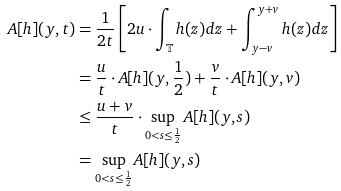<formula> <loc_0><loc_0><loc_500><loc_500>A [ h ] ( y , t ) & = \frac { 1 } { 2 t } \left [ 2 u \cdot \int _ { \mathbb { T } } h ( z ) d z + \int _ { y - v } ^ { y + v } h ( z ) d z \right ] \\ & = \frac { u } { t } \cdot A [ h ] ( y , \frac { 1 } { 2 } ) + \frac { v } { t } \cdot A [ h ] ( y , v ) \\ & \leq \frac { u + v } { t } \cdot \sup _ { 0 < s \leq \frac { 1 } { 2 } } A [ h ] ( y , s ) \\ & = \sup _ { 0 < s \leq \frac { 1 } { 2 } } A [ h ] ( y , s )</formula> 